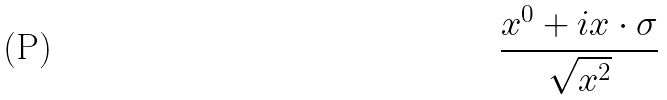<formula> <loc_0><loc_0><loc_500><loc_500>\frac { x ^ { 0 } + i x \cdot \sigma } { \sqrt { x ^ { 2 } } }</formula> 